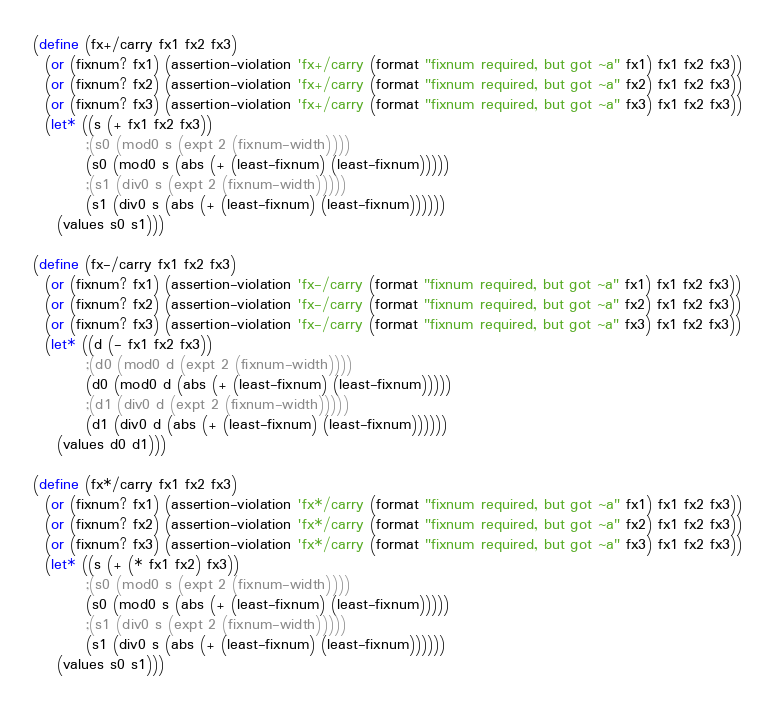<code> <loc_0><loc_0><loc_500><loc_500><_Scheme_>
(define (fx+/carry fx1 fx2 fx3)
  (or (fixnum? fx1) (assertion-violation 'fx+/carry (format "fixnum required, but got ~a" fx1) fx1 fx2 fx3))
  (or (fixnum? fx2) (assertion-violation 'fx+/carry (format "fixnum required, but got ~a" fx2) fx1 fx2 fx3))
  (or (fixnum? fx3) (assertion-violation 'fx+/carry (format "fixnum required, but got ~a" fx3) fx1 fx2 fx3))
  (let* ((s (+ fx1 fx2 fx3))
         ;(s0 (mod0 s (expt 2 (fixnum-width))))
         (s0 (mod0 s (abs (+ (least-fixnum) (least-fixnum)))))
         ;(s1 (div0 s (expt 2 (fixnum-width)))))
         (s1 (div0 s (abs (+ (least-fixnum) (least-fixnum))))))
    (values s0 s1)))

(define (fx-/carry fx1 fx2 fx3)
  (or (fixnum? fx1) (assertion-violation 'fx-/carry (format "fixnum required, but got ~a" fx1) fx1 fx2 fx3))
  (or (fixnum? fx2) (assertion-violation 'fx-/carry (format "fixnum required, but got ~a" fx2) fx1 fx2 fx3))
  (or (fixnum? fx3) (assertion-violation 'fx-/carry (format "fixnum required, but got ~a" fx3) fx1 fx2 fx3))
  (let* ((d (- fx1 fx2 fx3))
         ;(d0 (mod0 d (expt 2 (fixnum-width))))
         (d0 (mod0 d (abs (+ (least-fixnum) (least-fixnum)))))
         ;(d1 (div0 d (expt 2 (fixnum-width)))))
         (d1 (div0 d (abs (+ (least-fixnum) (least-fixnum))))))
    (values d0 d1)))

(define (fx*/carry fx1 fx2 fx3)
  (or (fixnum? fx1) (assertion-violation 'fx*/carry (format "fixnum required, but got ~a" fx1) fx1 fx2 fx3))
  (or (fixnum? fx2) (assertion-violation 'fx*/carry (format "fixnum required, but got ~a" fx2) fx1 fx2 fx3))
  (or (fixnum? fx3) (assertion-violation 'fx*/carry (format "fixnum required, but got ~a" fx3) fx1 fx2 fx3))
  (let* ((s (+ (* fx1 fx2) fx3))
         ;(s0 (mod0 s (expt 2 (fixnum-width))))
         (s0 (mod0 s (abs (+ (least-fixnum) (least-fixnum)))))
         ;(s1 (div0 s (expt 2 (fixnum-width)))))
         (s1 (div0 s (abs (+ (least-fixnum) (least-fixnum))))))
    (values s0 s1)))

</code> 